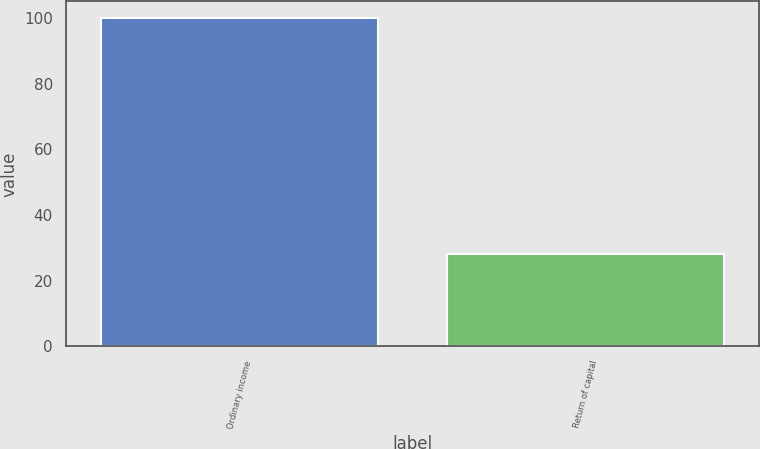<chart> <loc_0><loc_0><loc_500><loc_500><bar_chart><fcel>Ordinary income<fcel>Return of capital<nl><fcel>100<fcel>28<nl></chart> 